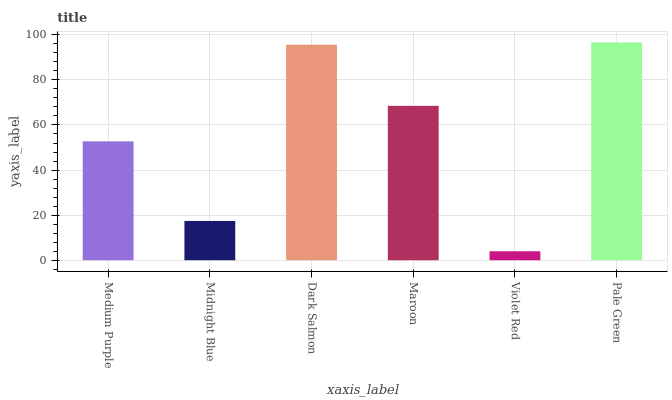Is Violet Red the minimum?
Answer yes or no. Yes. Is Pale Green the maximum?
Answer yes or no. Yes. Is Midnight Blue the minimum?
Answer yes or no. No. Is Midnight Blue the maximum?
Answer yes or no. No. Is Medium Purple greater than Midnight Blue?
Answer yes or no. Yes. Is Midnight Blue less than Medium Purple?
Answer yes or no. Yes. Is Midnight Blue greater than Medium Purple?
Answer yes or no. No. Is Medium Purple less than Midnight Blue?
Answer yes or no. No. Is Maroon the high median?
Answer yes or no. Yes. Is Medium Purple the low median?
Answer yes or no. Yes. Is Dark Salmon the high median?
Answer yes or no. No. Is Violet Red the low median?
Answer yes or no. No. 